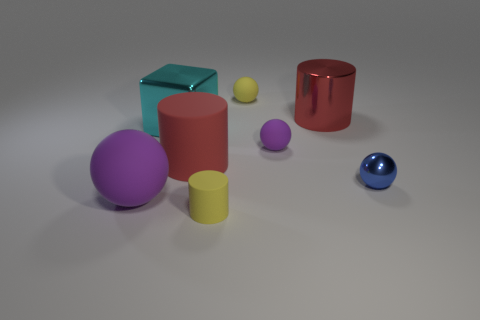There is a ball that is the same color as the tiny matte cylinder; what is its material?
Keep it short and to the point. Rubber. Does the blue sphere have the same size as the yellow sphere?
Give a very brief answer. Yes. Are there more big red things than big purple blocks?
Offer a terse response. Yes. How many other things are the same color as the large shiny cube?
Provide a succinct answer. 0. What number of things are either gray matte things or tiny yellow matte objects?
Make the answer very short. 2. There is a large metallic thing that is in front of the red metal object; does it have the same shape as the tiny metal thing?
Provide a succinct answer. No. What color is the ball left of the large cylinder in front of the large red metallic cylinder?
Your answer should be very brief. Purple. Are there fewer brown metal balls than tiny blue metallic spheres?
Your answer should be very brief. Yes. Are there any blue balls made of the same material as the cyan cube?
Make the answer very short. Yes. Do the large cyan metal object and the blue object on the right side of the large shiny block have the same shape?
Give a very brief answer. No. 